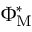Convert formula to latex. <formula><loc_0><loc_0><loc_500><loc_500>\Phi _ { M } ^ { * }</formula> 